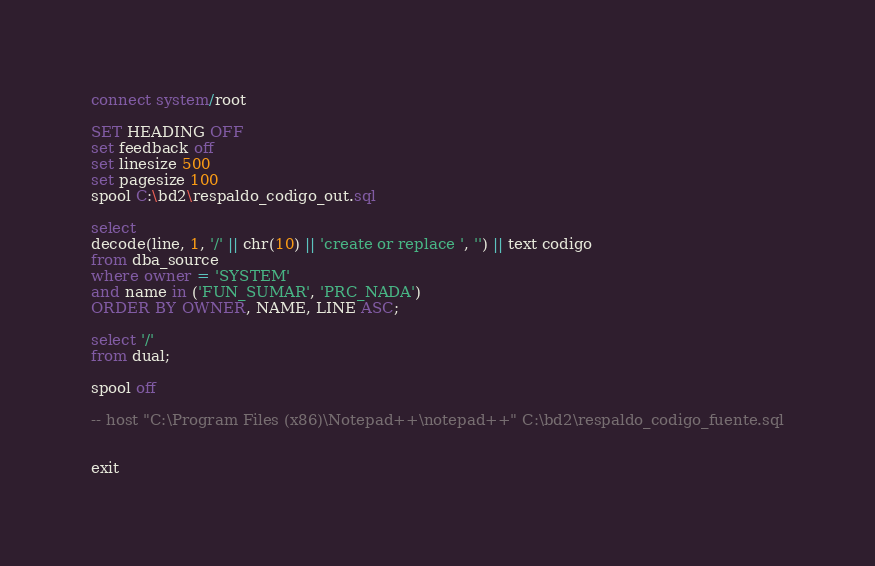<code> <loc_0><loc_0><loc_500><loc_500><_SQL_>
connect system/root

SET HEADING OFF
set feedback off
set linesize 500
set pagesize 100 
spool C:\bd2\respaldo_codigo_out.sql

select 
decode(line, 1, '/' || chr(10) || 'create or replace ', '') || text codigo
from dba_source
where owner = 'SYSTEM'
and name in ('FUN_SUMAR', 'PRC_NADA')
ORDER BY OWNER, NAME, LINE ASC;

select '/'
from dual;

spool off

-- host "C:\Program Files (x86)\Notepad++\notepad++" C:\bd2\respaldo_codigo_fuente.sql


exit</code> 